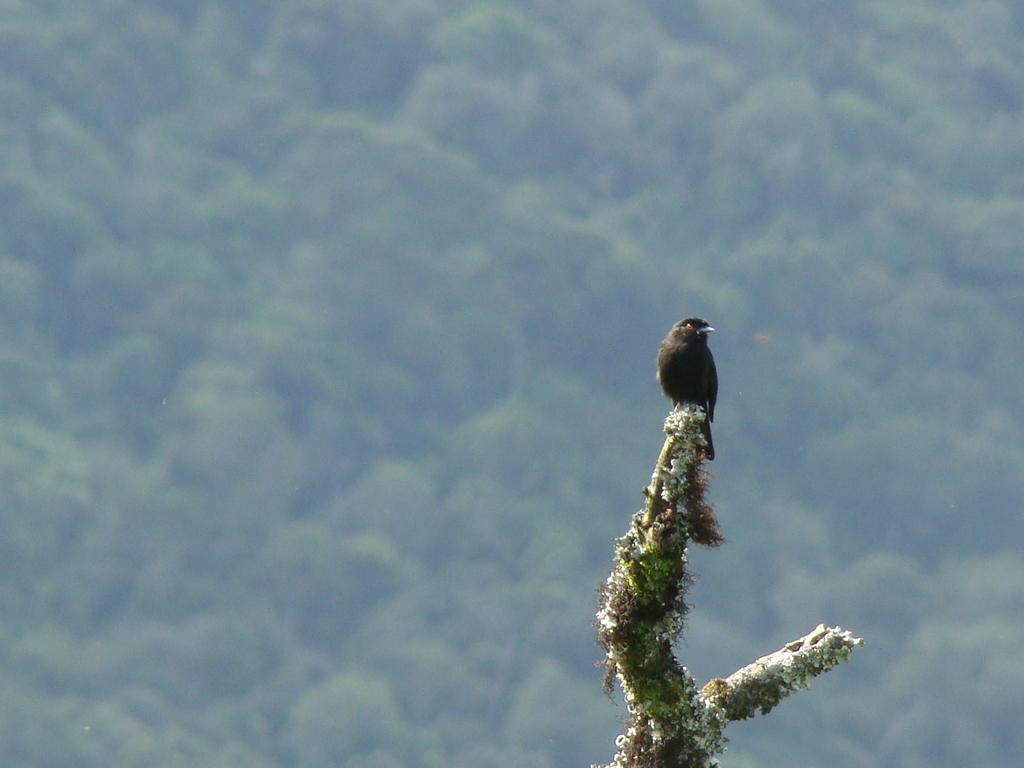What type of animal can be seen in the image? There is a bird in the image. Where is the bird located? The bird is on a tree. What can be seen in the background of the image? There are trees visible in the background of the image. What type of mailbox is located in the middle of the tree? There is no mailbox present in the image; it only features a bird on a tree and trees in the background. 